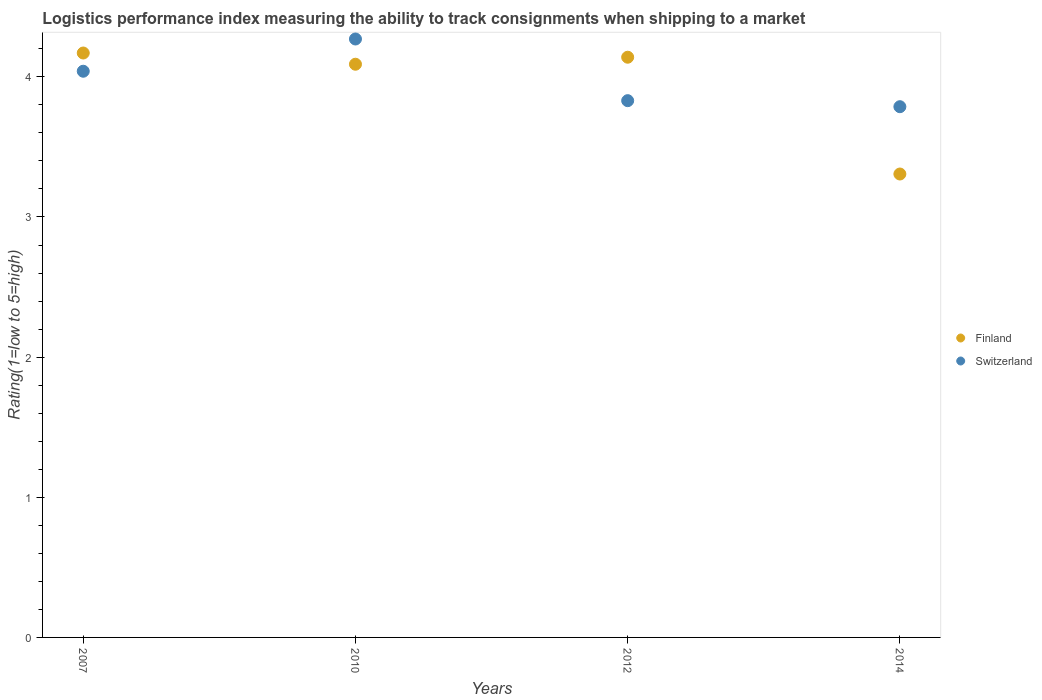How many different coloured dotlines are there?
Ensure brevity in your answer.  2. What is the Logistic performance index in Switzerland in 2010?
Ensure brevity in your answer.  4.27. Across all years, what is the maximum Logistic performance index in Finland?
Keep it short and to the point. 4.17. Across all years, what is the minimum Logistic performance index in Finland?
Give a very brief answer. 3.31. In which year was the Logistic performance index in Finland minimum?
Your answer should be compact. 2014. What is the total Logistic performance index in Finland in the graph?
Your answer should be compact. 15.71. What is the difference between the Logistic performance index in Switzerland in 2010 and that in 2014?
Your response must be concise. 0.48. What is the difference between the Logistic performance index in Switzerland in 2012 and the Logistic performance index in Finland in 2010?
Offer a very short reply. -0.26. What is the average Logistic performance index in Finland per year?
Provide a short and direct response. 3.93. In the year 2010, what is the difference between the Logistic performance index in Switzerland and Logistic performance index in Finland?
Give a very brief answer. 0.18. What is the ratio of the Logistic performance index in Finland in 2012 to that in 2014?
Give a very brief answer. 1.25. Is the Logistic performance index in Finland in 2012 less than that in 2014?
Keep it short and to the point. No. Is the difference between the Logistic performance index in Switzerland in 2012 and 2014 greater than the difference between the Logistic performance index in Finland in 2012 and 2014?
Provide a short and direct response. No. What is the difference between the highest and the second highest Logistic performance index in Finland?
Make the answer very short. 0.03. What is the difference between the highest and the lowest Logistic performance index in Switzerland?
Provide a short and direct response. 0.48. In how many years, is the Logistic performance index in Switzerland greater than the average Logistic performance index in Switzerland taken over all years?
Give a very brief answer. 2. Is the sum of the Logistic performance index in Finland in 2007 and 2010 greater than the maximum Logistic performance index in Switzerland across all years?
Your answer should be very brief. Yes. Does the graph contain any zero values?
Offer a terse response. No. Does the graph contain grids?
Your response must be concise. No. Where does the legend appear in the graph?
Your response must be concise. Center right. How are the legend labels stacked?
Your answer should be very brief. Vertical. What is the title of the graph?
Your response must be concise. Logistics performance index measuring the ability to track consignments when shipping to a market. Does "Korea (Republic)" appear as one of the legend labels in the graph?
Your response must be concise. No. What is the label or title of the Y-axis?
Your response must be concise. Rating(1=low to 5=high). What is the Rating(1=low to 5=high) in Finland in 2007?
Ensure brevity in your answer.  4.17. What is the Rating(1=low to 5=high) of Switzerland in 2007?
Your answer should be compact. 4.04. What is the Rating(1=low to 5=high) of Finland in 2010?
Offer a very short reply. 4.09. What is the Rating(1=low to 5=high) of Switzerland in 2010?
Make the answer very short. 4.27. What is the Rating(1=low to 5=high) in Finland in 2012?
Make the answer very short. 4.14. What is the Rating(1=low to 5=high) in Switzerland in 2012?
Your answer should be compact. 3.83. What is the Rating(1=low to 5=high) in Finland in 2014?
Give a very brief answer. 3.31. What is the Rating(1=low to 5=high) in Switzerland in 2014?
Provide a succinct answer. 3.79. Across all years, what is the maximum Rating(1=low to 5=high) in Finland?
Offer a very short reply. 4.17. Across all years, what is the maximum Rating(1=low to 5=high) in Switzerland?
Keep it short and to the point. 4.27. Across all years, what is the minimum Rating(1=low to 5=high) in Finland?
Make the answer very short. 3.31. Across all years, what is the minimum Rating(1=low to 5=high) in Switzerland?
Offer a very short reply. 3.79. What is the total Rating(1=low to 5=high) in Finland in the graph?
Keep it short and to the point. 15.71. What is the total Rating(1=low to 5=high) in Switzerland in the graph?
Ensure brevity in your answer.  15.93. What is the difference between the Rating(1=low to 5=high) of Switzerland in 2007 and that in 2010?
Your answer should be very brief. -0.23. What is the difference between the Rating(1=low to 5=high) in Switzerland in 2007 and that in 2012?
Offer a very short reply. 0.21. What is the difference between the Rating(1=low to 5=high) in Finland in 2007 and that in 2014?
Your answer should be very brief. 0.86. What is the difference between the Rating(1=low to 5=high) in Switzerland in 2007 and that in 2014?
Ensure brevity in your answer.  0.25. What is the difference between the Rating(1=low to 5=high) of Finland in 2010 and that in 2012?
Offer a terse response. -0.05. What is the difference between the Rating(1=low to 5=high) in Switzerland in 2010 and that in 2012?
Offer a very short reply. 0.44. What is the difference between the Rating(1=low to 5=high) in Finland in 2010 and that in 2014?
Provide a short and direct response. 0.78. What is the difference between the Rating(1=low to 5=high) of Switzerland in 2010 and that in 2014?
Offer a very short reply. 0.48. What is the difference between the Rating(1=low to 5=high) in Finland in 2012 and that in 2014?
Provide a succinct answer. 0.83. What is the difference between the Rating(1=low to 5=high) of Switzerland in 2012 and that in 2014?
Your response must be concise. 0.04. What is the difference between the Rating(1=low to 5=high) of Finland in 2007 and the Rating(1=low to 5=high) of Switzerland in 2010?
Provide a short and direct response. -0.1. What is the difference between the Rating(1=low to 5=high) of Finland in 2007 and the Rating(1=low to 5=high) of Switzerland in 2012?
Your answer should be very brief. 0.34. What is the difference between the Rating(1=low to 5=high) of Finland in 2007 and the Rating(1=low to 5=high) of Switzerland in 2014?
Your response must be concise. 0.38. What is the difference between the Rating(1=low to 5=high) of Finland in 2010 and the Rating(1=low to 5=high) of Switzerland in 2012?
Offer a terse response. 0.26. What is the difference between the Rating(1=low to 5=high) in Finland in 2010 and the Rating(1=low to 5=high) in Switzerland in 2014?
Offer a terse response. 0.3. What is the difference between the Rating(1=low to 5=high) of Finland in 2012 and the Rating(1=low to 5=high) of Switzerland in 2014?
Ensure brevity in your answer.  0.35. What is the average Rating(1=low to 5=high) of Finland per year?
Your response must be concise. 3.93. What is the average Rating(1=low to 5=high) in Switzerland per year?
Give a very brief answer. 3.98. In the year 2007, what is the difference between the Rating(1=low to 5=high) in Finland and Rating(1=low to 5=high) in Switzerland?
Make the answer very short. 0.13. In the year 2010, what is the difference between the Rating(1=low to 5=high) in Finland and Rating(1=low to 5=high) in Switzerland?
Give a very brief answer. -0.18. In the year 2012, what is the difference between the Rating(1=low to 5=high) in Finland and Rating(1=low to 5=high) in Switzerland?
Provide a succinct answer. 0.31. In the year 2014, what is the difference between the Rating(1=low to 5=high) in Finland and Rating(1=low to 5=high) in Switzerland?
Offer a terse response. -0.48. What is the ratio of the Rating(1=low to 5=high) in Finland in 2007 to that in 2010?
Provide a succinct answer. 1.02. What is the ratio of the Rating(1=low to 5=high) in Switzerland in 2007 to that in 2010?
Provide a succinct answer. 0.95. What is the ratio of the Rating(1=low to 5=high) in Finland in 2007 to that in 2012?
Ensure brevity in your answer.  1.01. What is the ratio of the Rating(1=low to 5=high) in Switzerland in 2007 to that in 2012?
Give a very brief answer. 1.05. What is the ratio of the Rating(1=low to 5=high) of Finland in 2007 to that in 2014?
Your answer should be very brief. 1.26. What is the ratio of the Rating(1=low to 5=high) in Switzerland in 2007 to that in 2014?
Offer a terse response. 1.07. What is the ratio of the Rating(1=low to 5=high) of Finland in 2010 to that in 2012?
Give a very brief answer. 0.99. What is the ratio of the Rating(1=low to 5=high) of Switzerland in 2010 to that in 2012?
Ensure brevity in your answer.  1.11. What is the ratio of the Rating(1=low to 5=high) in Finland in 2010 to that in 2014?
Make the answer very short. 1.24. What is the ratio of the Rating(1=low to 5=high) in Switzerland in 2010 to that in 2014?
Make the answer very short. 1.13. What is the ratio of the Rating(1=low to 5=high) in Finland in 2012 to that in 2014?
Provide a succinct answer. 1.25. What is the ratio of the Rating(1=low to 5=high) of Switzerland in 2012 to that in 2014?
Keep it short and to the point. 1.01. What is the difference between the highest and the second highest Rating(1=low to 5=high) of Switzerland?
Offer a very short reply. 0.23. What is the difference between the highest and the lowest Rating(1=low to 5=high) in Finland?
Make the answer very short. 0.86. What is the difference between the highest and the lowest Rating(1=low to 5=high) of Switzerland?
Offer a terse response. 0.48. 